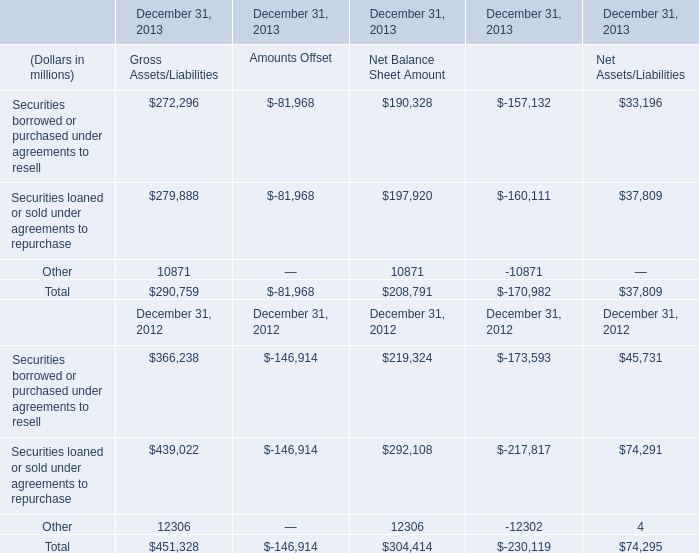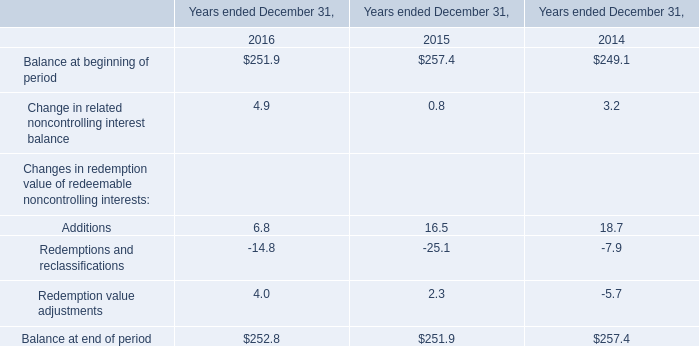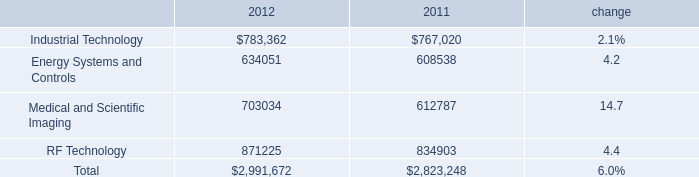What is the sum of Other of December 31, 2013 Net Balance Sheet Amount, and RF Technology of 2011 ? 
Computations: (10871.0 + 834903.0)
Answer: 845774.0. In which year is Securities borrowed or purchased under agreements to resell for Gross Assets/Liabilities positive? 
Answer: 2013 2012. 